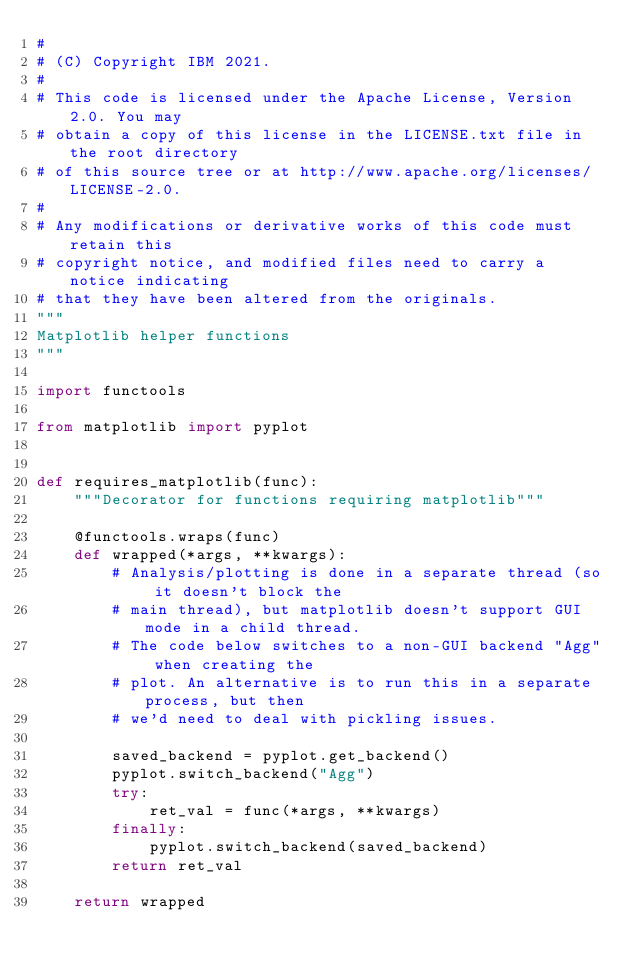<code> <loc_0><loc_0><loc_500><loc_500><_Python_>#
# (C) Copyright IBM 2021.
#
# This code is licensed under the Apache License, Version 2.0. You may
# obtain a copy of this license in the LICENSE.txt file in the root directory
# of this source tree or at http://www.apache.org/licenses/LICENSE-2.0.
#
# Any modifications or derivative works of this code must retain this
# copyright notice, and modified files need to carry a notice indicating
# that they have been altered from the originals.
"""
Matplotlib helper functions
"""

import functools

from matplotlib import pyplot


def requires_matplotlib(func):
    """Decorator for functions requiring matplotlib"""

    @functools.wraps(func)
    def wrapped(*args, **kwargs):
        # Analysis/plotting is done in a separate thread (so it doesn't block the
        # main thread), but matplotlib doesn't support GUI mode in a child thread.
        # The code below switches to a non-GUI backend "Agg" when creating the
        # plot. An alternative is to run this in a separate process, but then
        # we'd need to deal with pickling issues.

        saved_backend = pyplot.get_backend()
        pyplot.switch_backend("Agg")
        try:
            ret_val = func(*args, **kwargs)
        finally:
            pyplot.switch_backend(saved_backend)
        return ret_val

    return wrapped
</code> 